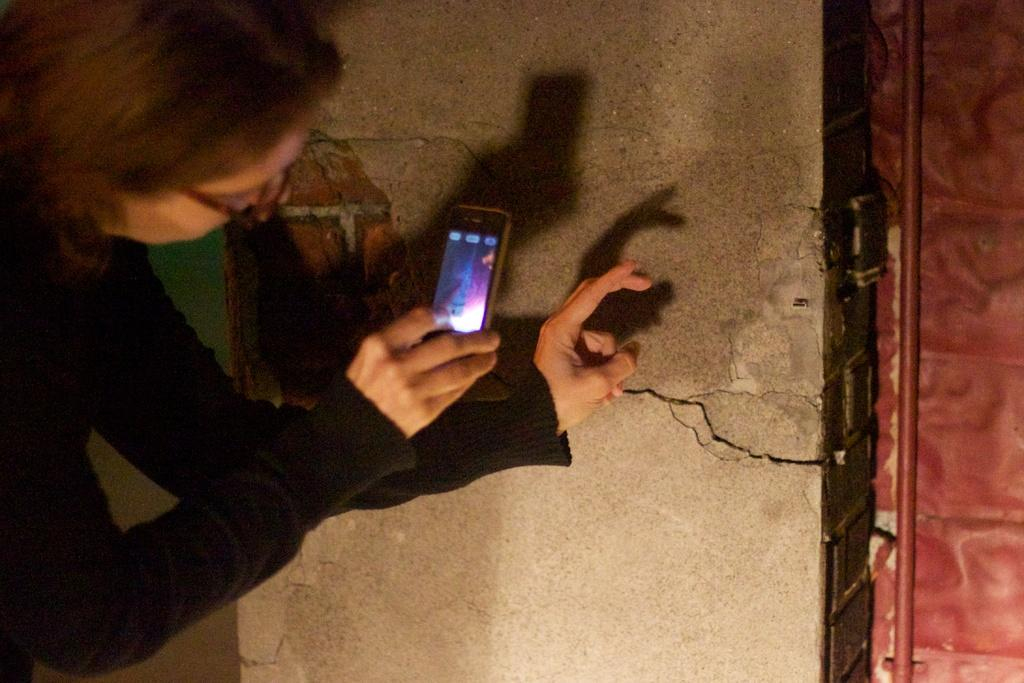What is the person in the image holding? The person is holding a mobile phone in the image. What can be seen behind the person in the image? There is a wall visible in the image. What type of structure can be seen in the image? There is a pipeline in the image. What is the father's opinion about the fog in the image? There is no father or fog present in the image, so it is not possible to answer that question. 